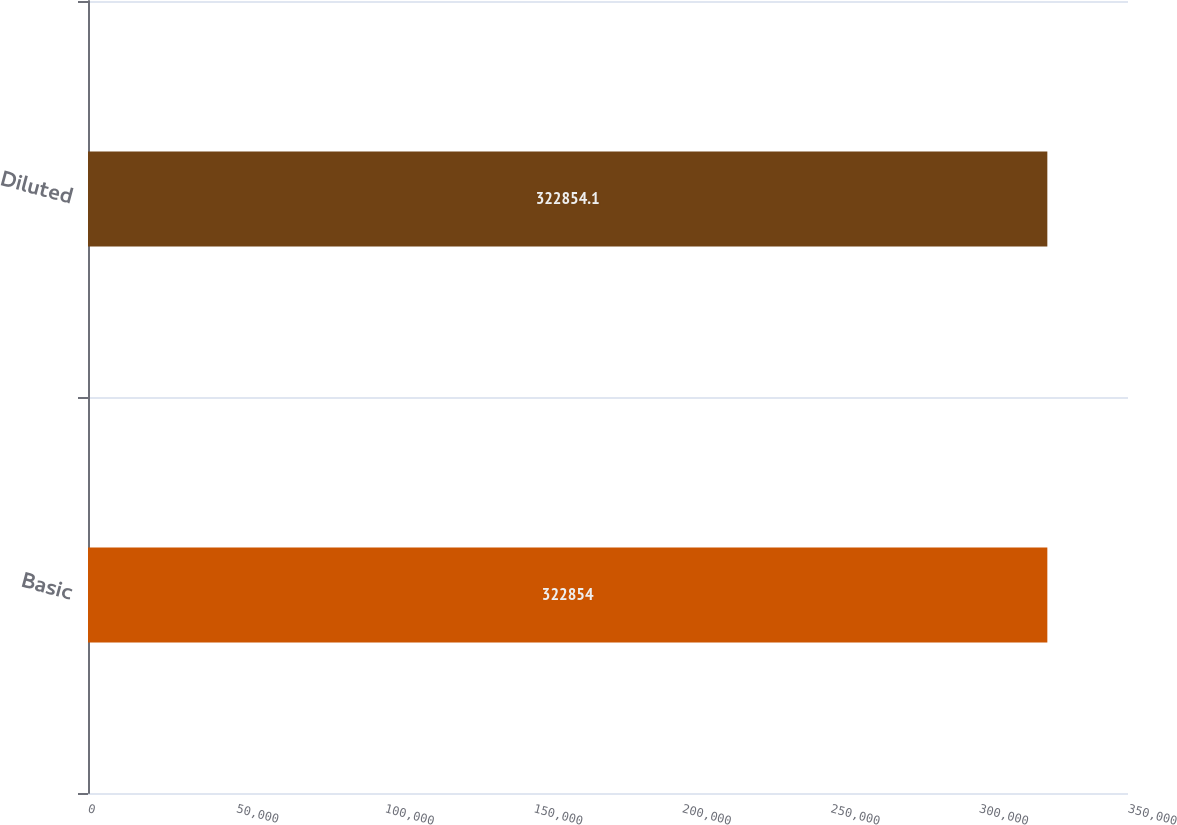Convert chart. <chart><loc_0><loc_0><loc_500><loc_500><bar_chart><fcel>Basic<fcel>Diluted<nl><fcel>322854<fcel>322854<nl></chart> 